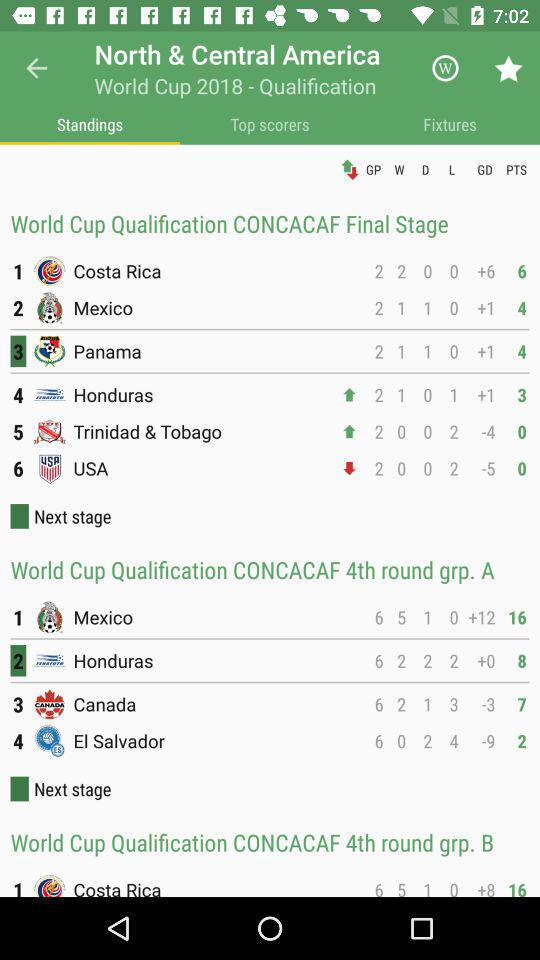What's the GD of "Canada" in "CONCACAF 4th round grp. A"? The GD of "Canada" in "CONCACAF 4th round grp. A" is -3. 